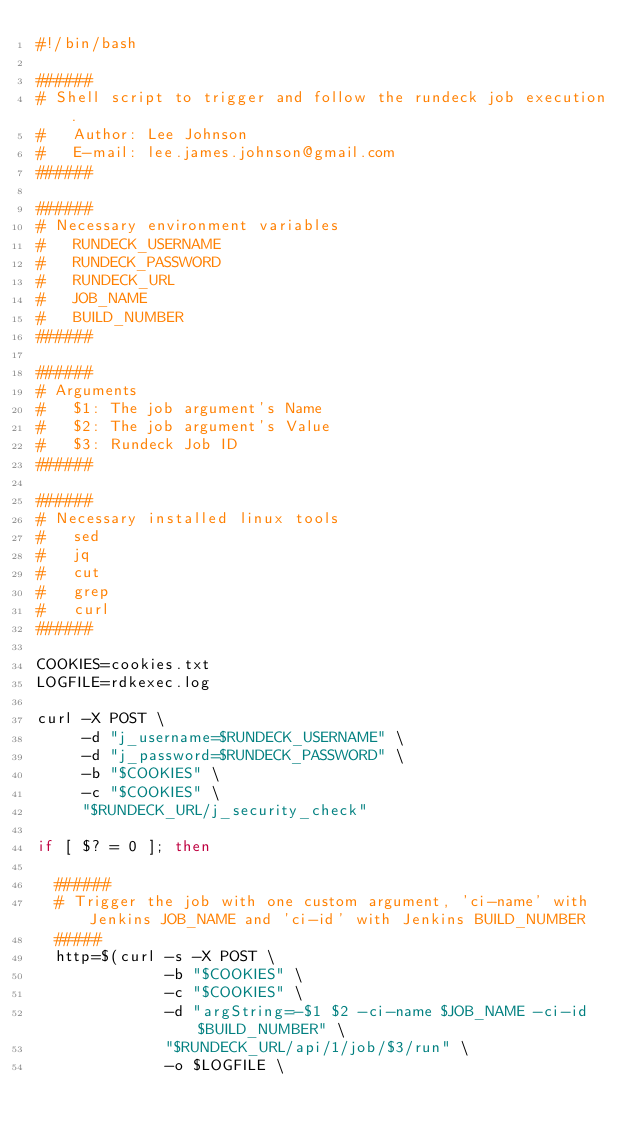Convert code to text. <code><loc_0><loc_0><loc_500><loc_500><_Bash_>#!/bin/bash

######
# Shell script to trigger and follow the rundeck job execution.
#   Author: Lee Johnson
#   E-mail: lee.james.johnson@gmail.com
######

######
# Necessary environment variables
#   RUNDECK_USERNAME
#   RUNDECK_PASSWORD
#   RUNDECK_URL
#   JOB_NAME
#   BUILD_NUMBER
######

######
# Arguments
#   $1: The job argument's Name
#   $2: The job argument's Value
#   $3: Rundeck Job ID
######

######
# Necessary installed linux tools
#   sed
#   jq
#   cut
#   grep
#   curl 
######

COOKIES=cookies.txt
LOGFILE=rdkexec.log

curl -X POST \
     -d "j_username=$RUNDECK_USERNAME" \
     -d "j_password=$RUNDECK_PASSWORD" \
     -b "$COOKIES" \
     -c "$COOKIES" \
     "$RUNDECK_URL/j_security_check"

if [ $? = 0 ]; then

  ######
  # Trigger the job with one custom argument, 'ci-name' with Jenkins JOB_NAME and 'ci-id' with Jenkins BUILD_NUMBER
  #####
  http=$(curl -s -X POST \
              -b "$COOKIES" \
              -c "$COOKIES" \
              -d "argString=-$1 $2 -ci-name $JOB_NAME -ci-id $BUILD_NUMBER" \
              "$RUNDECK_URL/api/1/job/$3/run" \
              -o $LOGFILE \</code> 